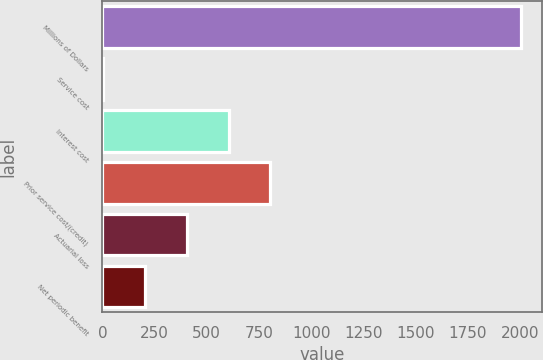<chart> <loc_0><loc_0><loc_500><loc_500><bar_chart><fcel>Millions of Dollars<fcel>Service cost<fcel>Interest cost<fcel>Prior service cost/(credit)<fcel>Actuarial loss<fcel>Net periodic benefit<nl><fcel>2006<fcel>4<fcel>604.6<fcel>804.8<fcel>404.4<fcel>204.2<nl></chart> 